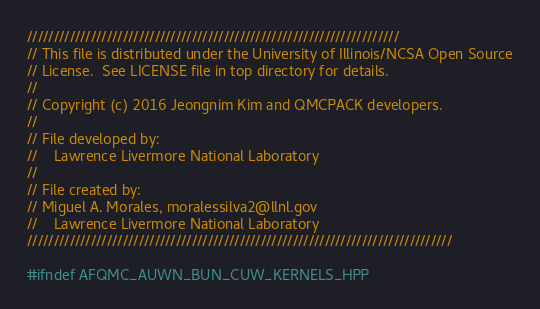<code> <loc_0><loc_0><loc_500><loc_500><_Cuda_>//////////////////////////////////////////////////////////////////////
// This file is distributed under the University of Illinois/NCSA Open Source
// License.  See LICENSE file in top directory for details.
//
// Copyright (c) 2016 Jeongnim Kim and QMCPACK developers.
//
// File developed by:
//    Lawrence Livermore National Laboratory
//
// File created by:
// Miguel A. Morales, moralessilva2@llnl.gov
//    Lawrence Livermore National Laboratory
////////////////////////////////////////////////////////////////////////////////

#ifndef AFQMC_AUWN_BUN_CUW_KERNELS_HPP</code> 